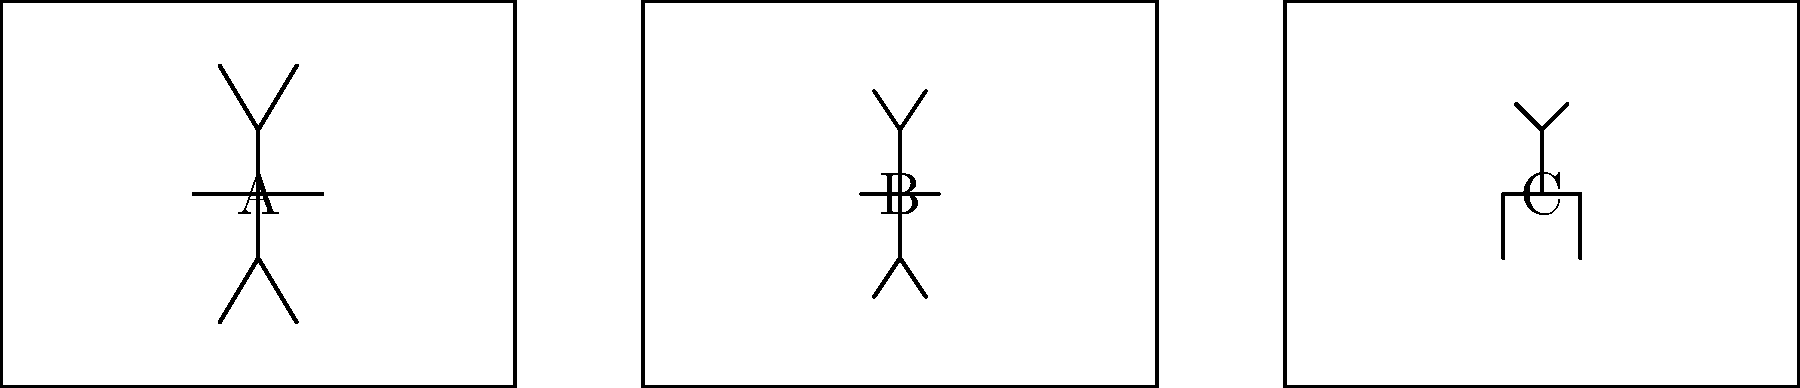As a cinematographer who has worked with Jean Harlez, you're familiar with various shot types. Analyze the storyboard-style illustrations above and identify which frame represents a medium shot. To answer this question, let's analyze each frame in the storyboard:

1. Frame A: This frame shows a full-body view of a person from head to toe. This is typically classified as a full shot or long shot, as it captures the entire figure within the frame.

2. Frame B: This frame shows a person from approximately the waist up. It provides more detail of the upper body and facial expressions while still showing some of the surrounding environment. This is characteristic of a medium shot.

3. Frame C: This frame shows only the upper part of a person's body, focusing on the head and shoulders. This is typically classified as a close-up shot, as it emphasizes facial expressions and emotions.

In cinematography, a medium shot is generally defined as a camera angle that shows the subject from the waist up. It's a versatile shot that balances showing the subject's body language and facial expressions with some context of the surrounding environment.

Given these definitions and the analysis of the frames, Frame B best represents a medium shot.
Answer: B 